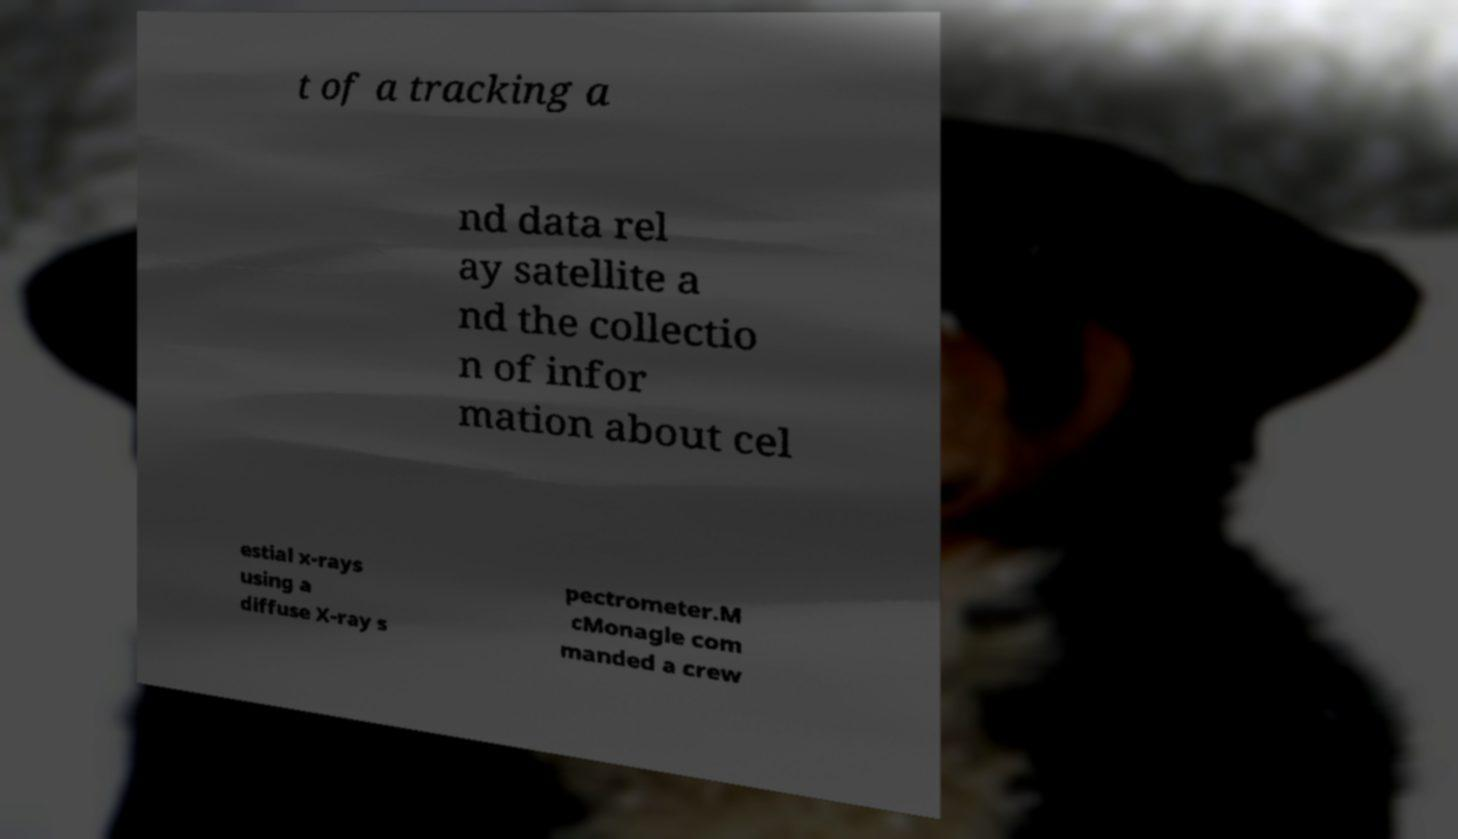For documentation purposes, I need the text within this image transcribed. Could you provide that? t of a tracking a nd data rel ay satellite a nd the collectio n of infor mation about cel estial x-rays using a diffuse X-ray s pectrometer.M cMonagle com manded a crew 